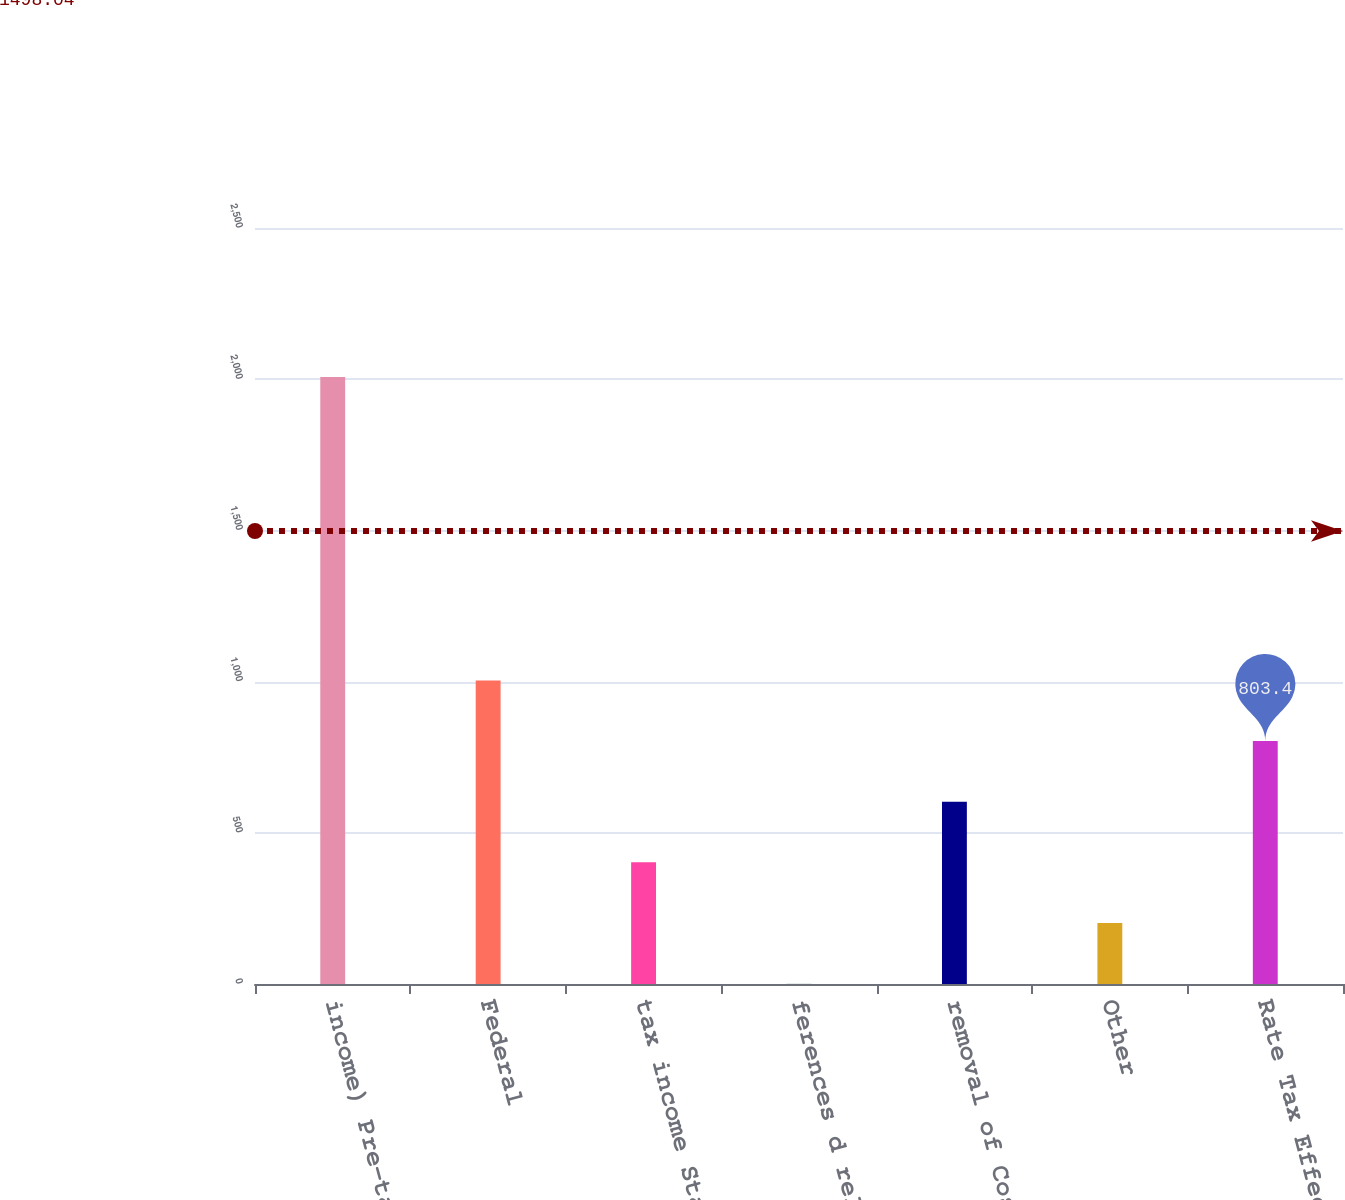Convert chart. <chart><loc_0><loc_0><loc_500><loc_500><bar_chart><fcel>income) Pre-tax of (<fcel>Federal<fcel>tax income State<fcel>ferences d related<fcel>removal of Cost<fcel>Other<fcel>Rate Tax Effective<nl><fcel>2007<fcel>1004<fcel>402.2<fcel>1<fcel>602.8<fcel>201.6<fcel>803.4<nl></chart> 